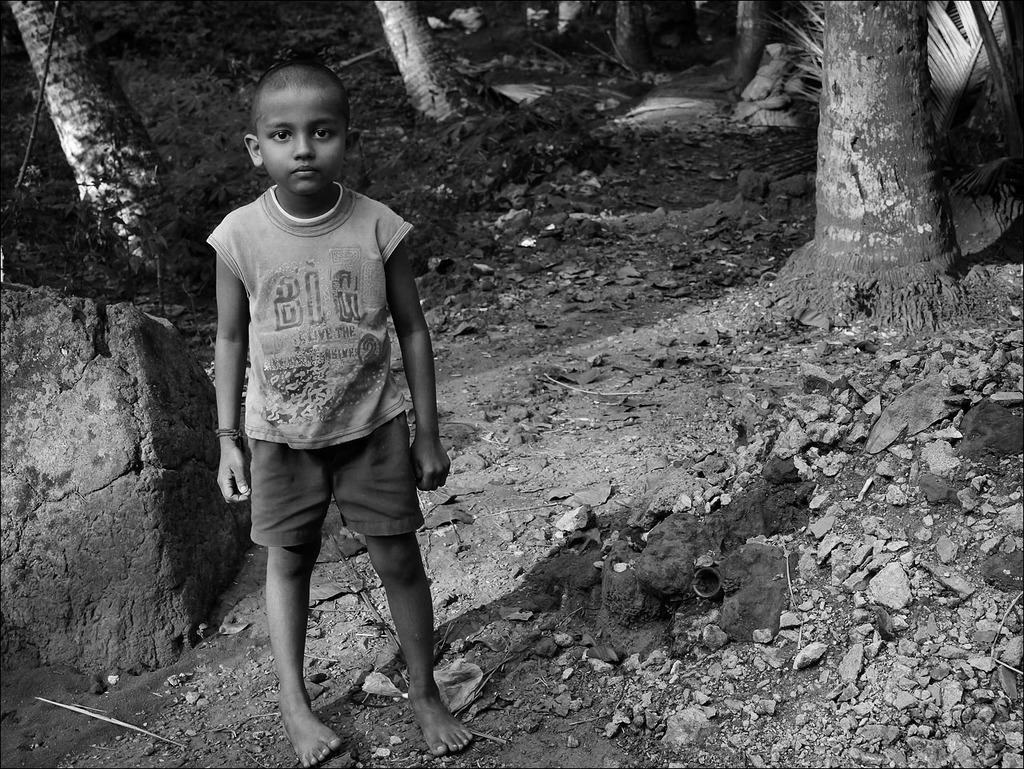Please provide a concise description of this image. This is a black and white image. In this image we can see a child standing on the ground. We can also see some stones, plants, the rock and the bark of the trees. 